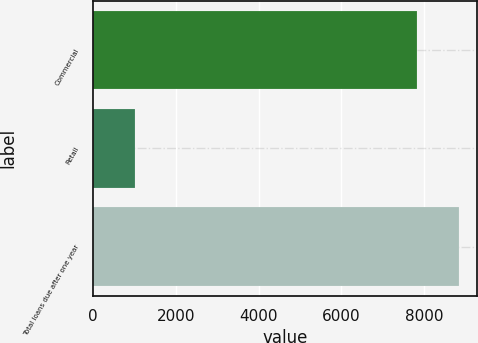Convert chart to OTSL. <chart><loc_0><loc_0><loc_500><loc_500><bar_chart><fcel>Commercial<fcel>Retail<fcel>Total loans due after one year<nl><fcel>7825.8<fcel>1018<fcel>8843.8<nl></chart> 